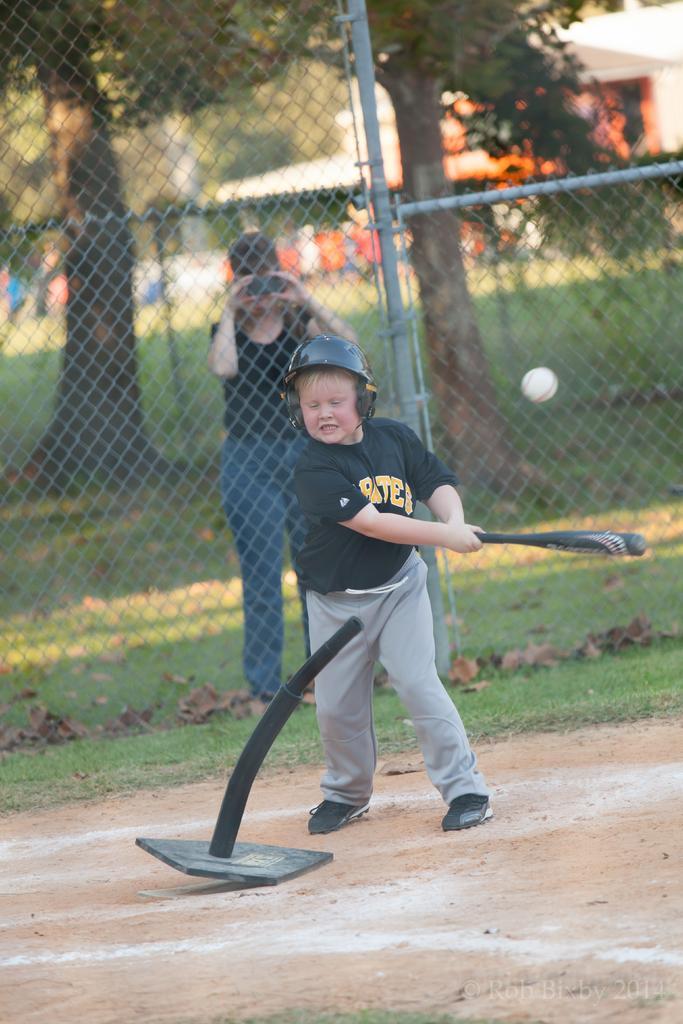Please provide a concise description of this image. In this image there is one woman and one boy woman is holding a camera, and boy is holding a bat and playing and in front of him there is object. And at the bottom there is sand grass and some dry leaves, in the background there are buildings, trees and there is a net. 